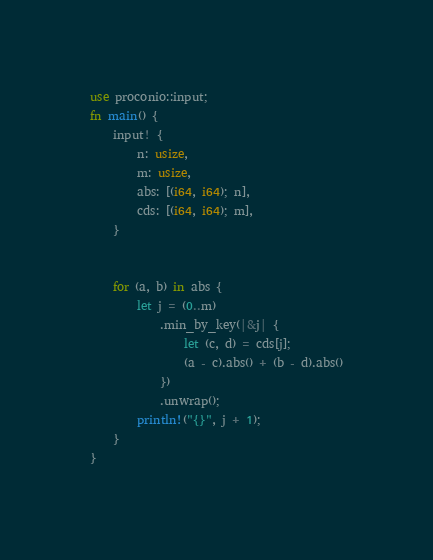Convert code to text. <code><loc_0><loc_0><loc_500><loc_500><_Rust_>use proconio::input;
fn main() {
    input! {
        n: usize,
        m: usize,
        abs: [(i64, i64); n],
        cds: [(i64, i64); m],
    }
    
    
    for (a, b) in abs {
        let j = (0..m)
            .min_by_key(|&j| {
                let (c, d) = cds[j];
                (a - c).abs() + (b - d).abs()
            })
            .unwrap();
        println!("{}", j + 1);
    }
}</code> 